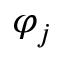Convert formula to latex. <formula><loc_0><loc_0><loc_500><loc_500>\varphi _ { j }</formula> 